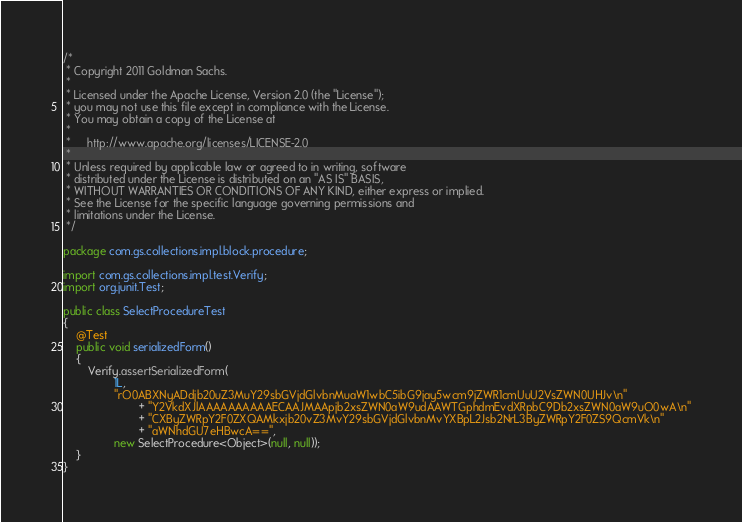<code> <loc_0><loc_0><loc_500><loc_500><_Java_>/*
 * Copyright 2011 Goldman Sachs.
 *
 * Licensed under the Apache License, Version 2.0 (the "License");
 * you may not use this file except in compliance with the License.
 * You may obtain a copy of the License at
 *
 *     http://www.apache.org/licenses/LICENSE-2.0
 *
 * Unless required by applicable law or agreed to in writing, software
 * distributed under the License is distributed on an "AS IS" BASIS,
 * WITHOUT WARRANTIES OR CONDITIONS OF ANY KIND, either express or implied.
 * See the License for the specific language governing permissions and
 * limitations under the License.
 */

package com.gs.collections.impl.block.procedure;

import com.gs.collections.impl.test.Verify;
import org.junit.Test;

public class SelectProcedureTest
{
    @Test
    public void serializedForm()
    {
        Verify.assertSerializedForm(
                1L,
                "rO0ABXNyADdjb20uZ3MuY29sbGVjdGlvbnMuaW1wbC5ibG9jay5wcm9jZWR1cmUuU2VsZWN0UHJv\n"
                        + "Y2VkdXJlAAAAAAAAAAECAAJMAApjb2xsZWN0aW9udAAWTGphdmEvdXRpbC9Db2xsZWN0aW9uO0wA\n"
                        + "CXByZWRpY2F0ZXQAMkxjb20vZ3MvY29sbGVjdGlvbnMvYXBpL2Jsb2NrL3ByZWRpY2F0ZS9QcmVk\n"
                        + "aWNhdGU7eHBwcA==",
                new SelectProcedure<Object>(null, null));
    }
}
</code> 